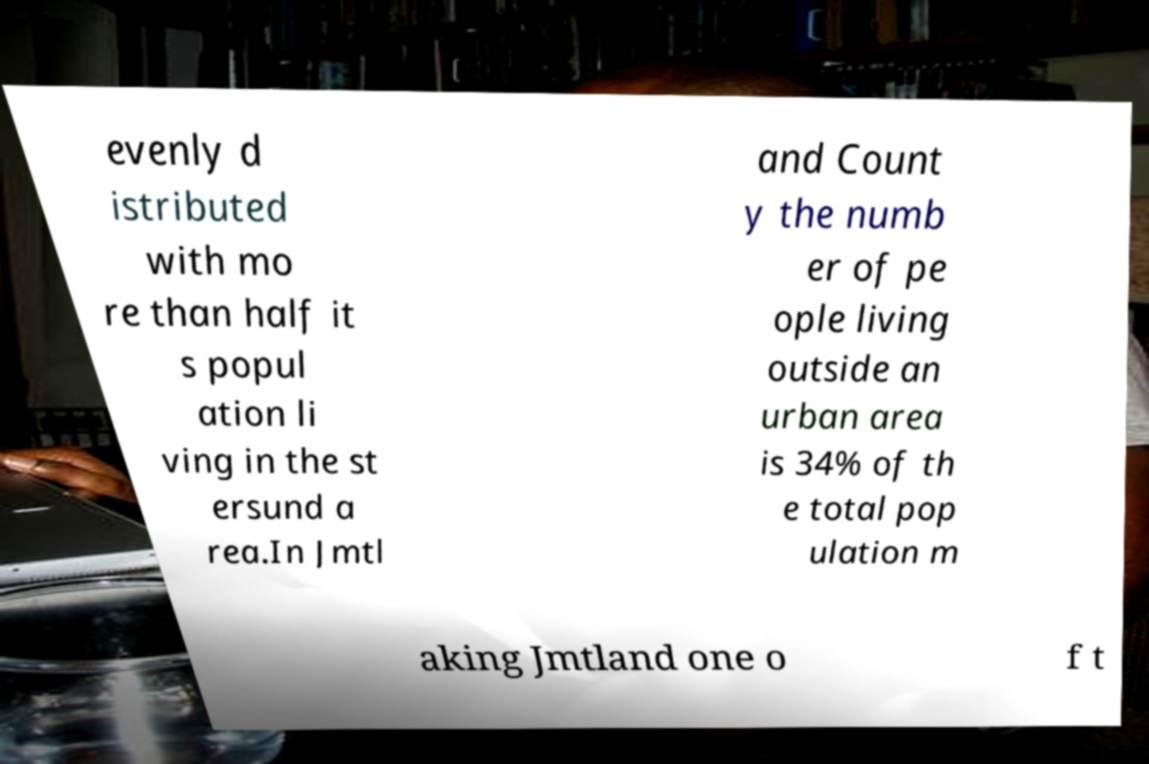Please identify and transcribe the text found in this image. evenly d istributed with mo re than half it s popul ation li ving in the st ersund a rea.In Jmtl and Count y the numb er of pe ople living outside an urban area is 34% of th e total pop ulation m aking Jmtland one o f t 